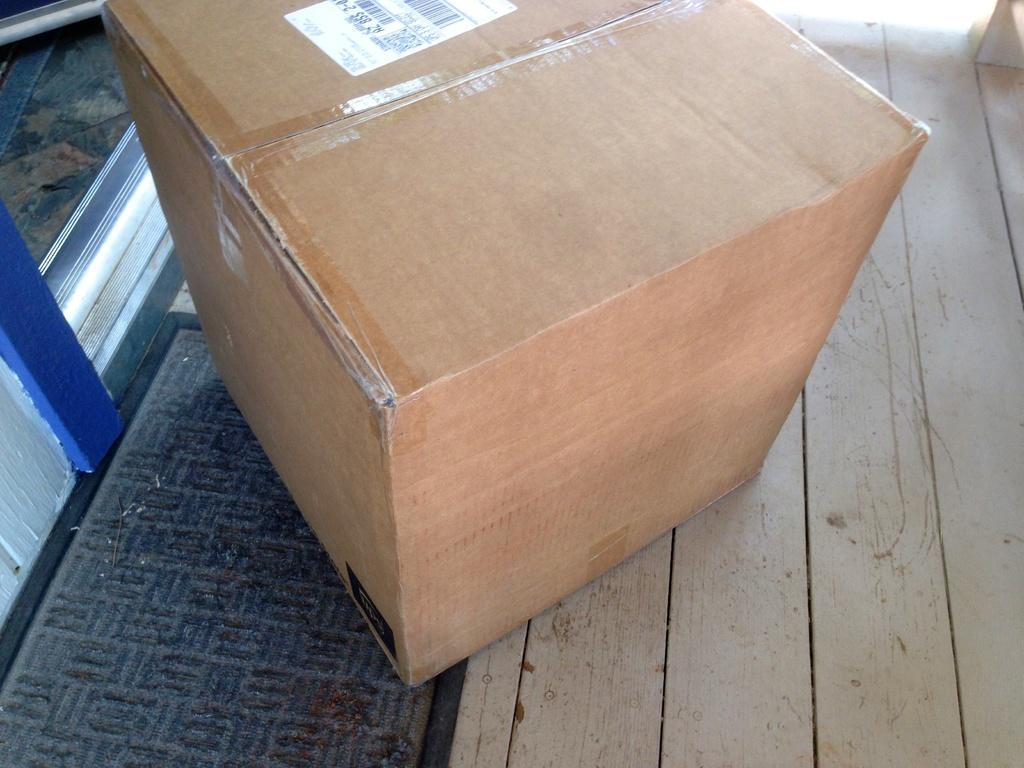In one or two sentences, can you explain what this image depicts? In this image, we can see a carton box on the wooden surface. 